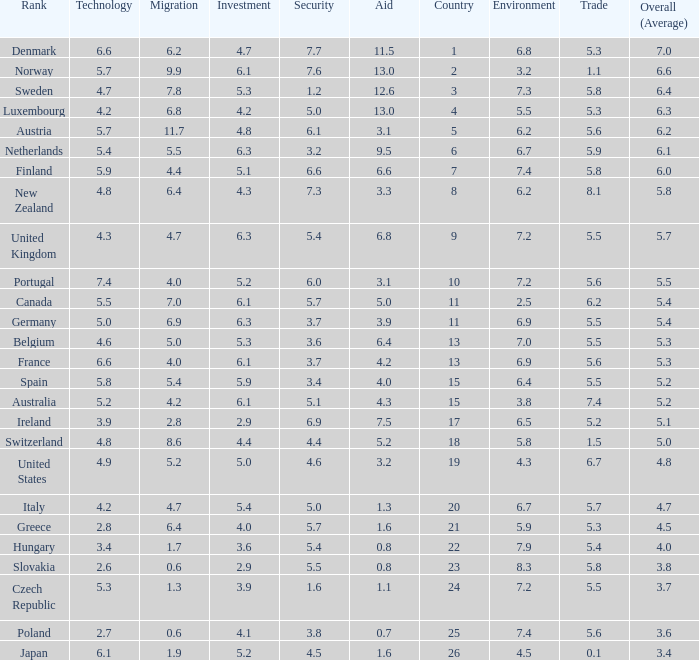How many times is denmark ranked in technology? 1.0. Could you parse the entire table? {'header': ['Rank', 'Technology', 'Migration', 'Investment', 'Security', 'Aid', 'Country', 'Environment', 'Trade', 'Overall (Average)'], 'rows': [['Denmark', '6.6', '6.2', '4.7', '7.7', '11.5', '1', '6.8', '5.3', '7.0'], ['Norway', '5.7', '9.9', '6.1', '7.6', '13.0', '2', '3.2', '1.1', '6.6'], ['Sweden', '4.7', '7.8', '5.3', '1.2', '12.6', '3', '7.3', '5.8', '6.4'], ['Luxembourg', '4.2', '6.8', '4.2', '5.0', '13.0', '4', '5.5', '5.3', '6.3'], ['Austria', '5.7', '11.7', '4.8', '6.1', '3.1', '5', '6.2', '5.6', '6.2'], ['Netherlands', '5.4', '5.5', '6.3', '3.2', '9.5', '6', '6.7', '5.9', '6.1'], ['Finland', '5.9', '4.4', '5.1', '6.6', '6.6', '7', '7.4', '5.8', '6.0'], ['New Zealand', '4.8', '6.4', '4.3', '7.3', '3.3', '8', '6.2', '8.1', '5.8'], ['United Kingdom', '4.3', '4.7', '6.3', '5.4', '6.8', '9', '7.2', '5.5', '5.7'], ['Portugal', '7.4', '4.0', '5.2', '6.0', '3.1', '10', '7.2', '5.6', '5.5'], ['Canada', '5.5', '7.0', '6.1', '5.7', '5.0', '11', '2.5', '6.2', '5.4'], ['Germany', '5.0', '6.9', '6.3', '3.7', '3.9', '11', '6.9', '5.5', '5.4'], ['Belgium', '4.6', '5.0', '5.3', '3.6', '6.4', '13', '7.0', '5.5', '5.3'], ['France', '6.6', '4.0', '6.1', '3.7', '4.2', '13', '6.9', '5.6', '5.3'], ['Spain', '5.8', '5.4', '5.9', '3.4', '4.0', '15', '6.4', '5.5', '5.2'], ['Australia', '5.2', '4.2', '6.1', '5.1', '4.3', '15', '3.8', '7.4', '5.2'], ['Ireland', '3.9', '2.8', '2.9', '6.9', '7.5', '17', '6.5', '5.2', '5.1'], ['Switzerland', '4.8', '8.6', '4.4', '4.4', '5.2', '18', '5.8', '1.5', '5.0'], ['United States', '4.9', '5.2', '5.0', '4.6', '3.2', '19', '4.3', '6.7', '4.8'], ['Italy', '4.2', '4.7', '5.4', '5.0', '1.3', '20', '6.7', '5.7', '4.7'], ['Greece', '2.8', '6.4', '4.0', '5.7', '1.6', '21', '5.9', '5.3', '4.5'], ['Hungary', '3.4', '1.7', '3.6', '5.4', '0.8', '22', '7.9', '5.4', '4.0'], ['Slovakia', '2.6', '0.6', '2.9', '5.5', '0.8', '23', '8.3', '5.8', '3.8'], ['Czech Republic', '5.3', '1.3', '3.9', '1.6', '1.1', '24', '7.2', '5.5', '3.7'], ['Poland', '2.7', '0.6', '4.1', '3.8', '0.7', '25', '7.4', '5.6', '3.6'], ['Japan', '6.1', '1.9', '5.2', '4.5', '1.6', '26', '4.5', '0.1', '3.4']]} 